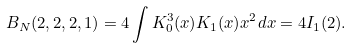Convert formula to latex. <formula><loc_0><loc_0><loc_500><loc_500>B _ { N } ( 2 , 2 , 2 , 1 ) = 4 \int K _ { 0 } ^ { 3 } ( x ) K _ { 1 } ( x ) x ^ { 2 } d x = 4 I _ { 1 } ( 2 ) .</formula> 